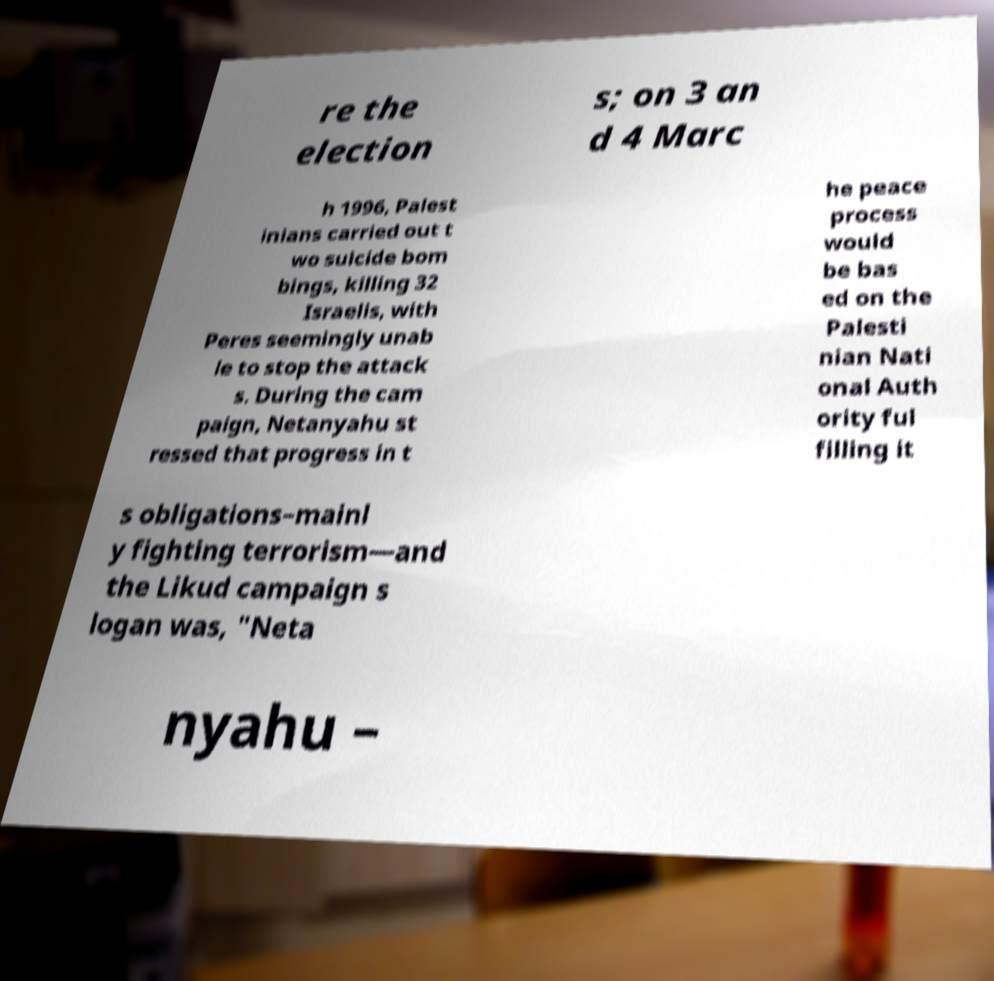I need the written content from this picture converted into text. Can you do that? re the election s; on 3 an d 4 Marc h 1996, Palest inians carried out t wo suicide bom bings, killing 32 Israelis, with Peres seemingly unab le to stop the attack s. During the cam paign, Netanyahu st ressed that progress in t he peace process would be bas ed on the Palesti nian Nati onal Auth ority ful filling it s obligations–mainl y fighting terrorism—and the Likud campaign s logan was, "Neta nyahu – 